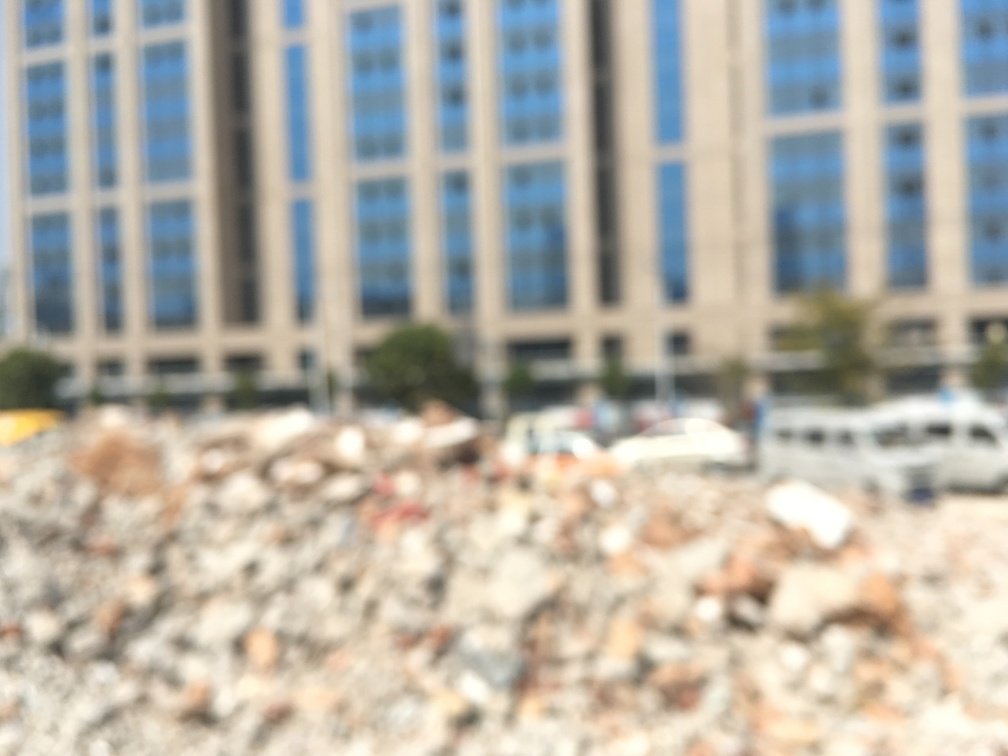Are the buildings and cars clear in the image?
A. Sharp
B. Detailed
C. Unclear
D. Visible
Answer with the option's letter from the given choices directly.
 C. 